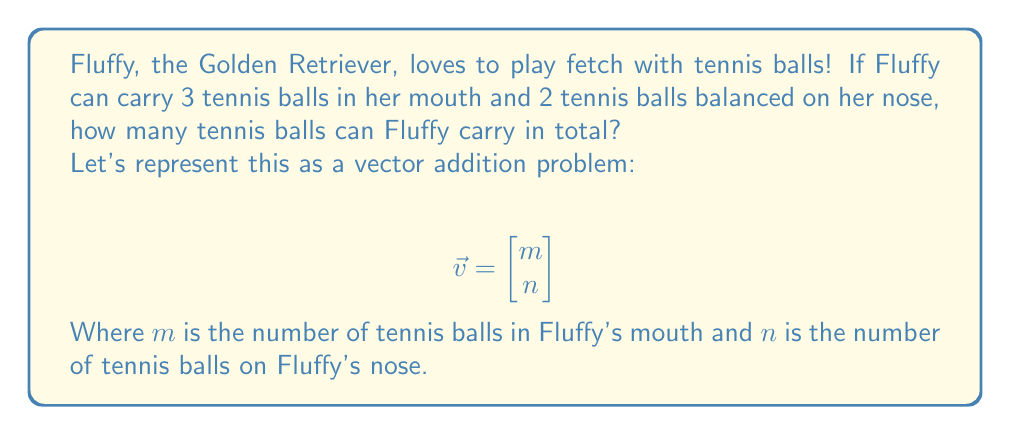Give your solution to this math problem. Let's approach this step-by-step:

1. We need to create two vectors:
   $$\vec{v}_1 = \begin{bmatrix} 3 \\ 0 \end{bmatrix}$$ (representing the balls in Fluffy's mouth)
   $$\vec{v}_2 = \begin{bmatrix} 0 \\ 2 \end{bmatrix}$$ (representing the balls on Fluffy's nose)

2. To find the total number of tennis balls, we need to add these vectors:
   $$\vec{v}_{total} = \vec{v}_1 + \vec{v}_2$$

3. In linear algebra, we add vectors by adding their corresponding components:
   $$\vec{v}_{total} = \begin{bmatrix} 3 \\ 0 \end{bmatrix} + \begin{bmatrix} 0 \\ 2 \end{bmatrix} = \begin{bmatrix} 3+0 \\ 0+2 \end{bmatrix} = \begin{bmatrix} 3 \\ 2 \end{bmatrix}$$

4. The resulting vector shows us that Fluffy can carry 3 balls in her mouth and 2 on her nose.

5. To find the total number of tennis balls, we sum the components of the final vector:
   $total = 3 + 2 = 5$
Answer: Fluffy the Golden Retriever can carry a total of 5 tennis balls. 